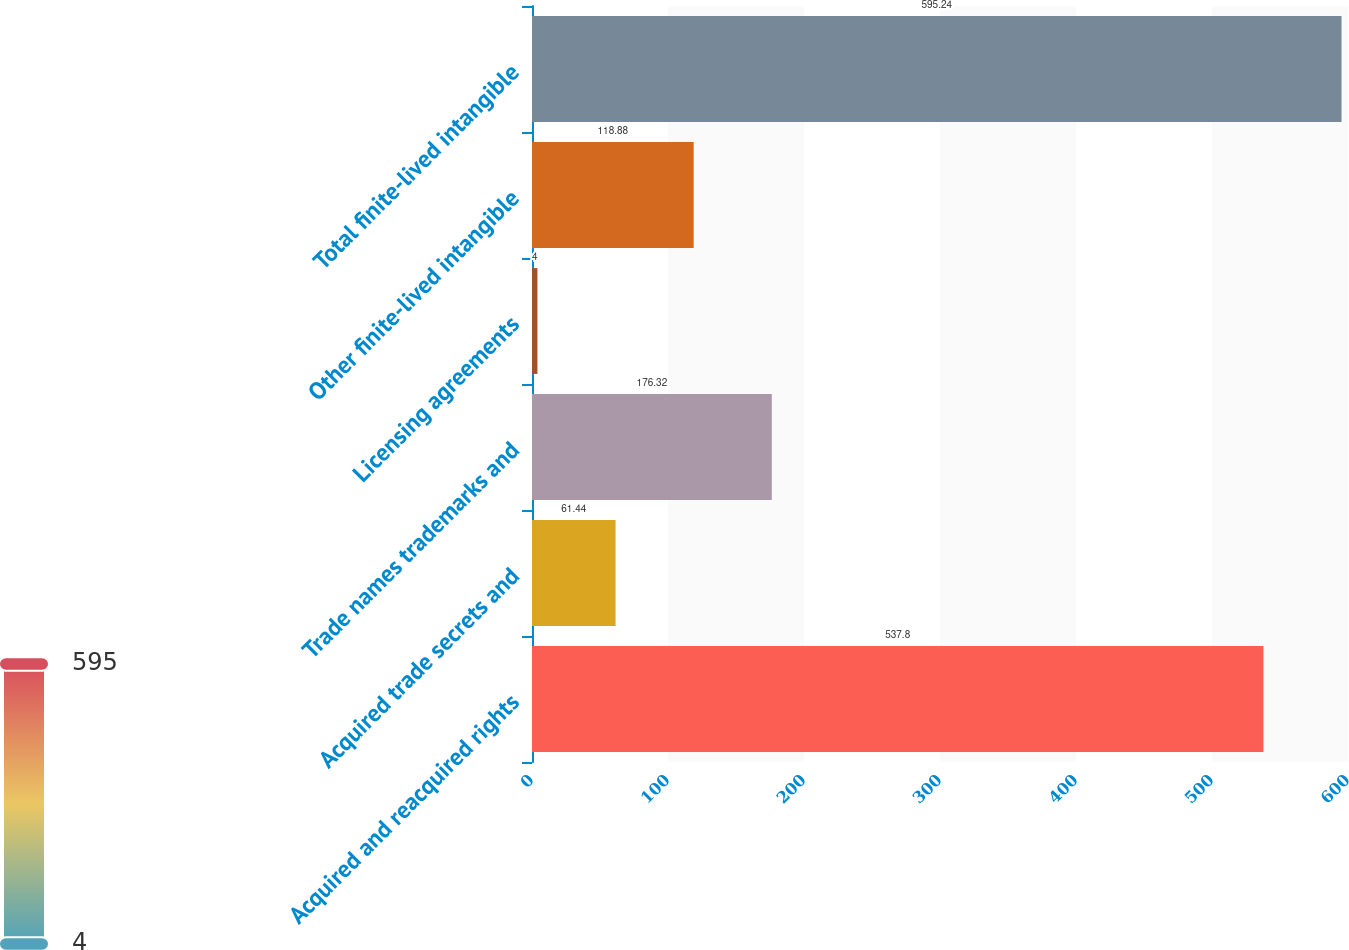Convert chart. <chart><loc_0><loc_0><loc_500><loc_500><bar_chart><fcel>Acquired and reacquired rights<fcel>Acquired trade secrets and<fcel>Trade names trademarks and<fcel>Licensing agreements<fcel>Other finite-lived intangible<fcel>Total finite-lived intangible<nl><fcel>537.8<fcel>61.44<fcel>176.32<fcel>4<fcel>118.88<fcel>595.24<nl></chart> 